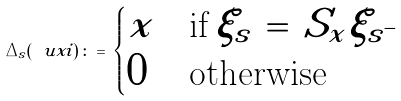Convert formula to latex. <formula><loc_0><loc_0><loc_500><loc_500>\Delta _ { s } ( \ u x i ) \, \colon = \, \begin{cases} x & \text {if} \, \xi _ { s } \, = \, S _ { x } \xi _ { s ^ { - } } \\ 0 & \text {otherwise} \end{cases}</formula> 